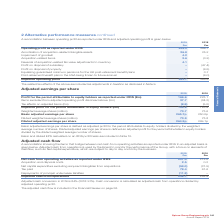According to Spirax Sarco Engineering Plc's financial document, How is basic adjusted earnings per share defined as? adjusted profit for the period attributable to equity holders divided by the weighted average number of shares. The document states: "Basic adjusted earnings per share is defined as adjusted profit for the period attributable to equity holders divided by the weighted average number o..." Also, How is diluted adjusted earnings per share defined as? adjusted profit for the period attributable to equity holders divided by the diluted weighted average number of shares. The document states: "Diluted adjusted earnings per share is defined as adjusted profit for the period attributable to equity holders divided by the diluted weighted averag..." Also, What is the Tax effects on adjusted items for 2018 and 2019 respectively? The document shows two values: (5.0) and (8.5) (in millions). From the document: ".7 (34.2) Tax effects on adjusted items (£m) (8.5) (5.0) Adjusted profit for the period attributable to equity holders (£m) 195.8 183.9 Weighted avera..." Additionally, In which year was the basic adjusted earnings per share larger? According to the financial document, 2019. The relevant text states: "2019 2018 Profit for the period attributable to equity holders as reported under IFRS (£m) 166.6 223.1 I..." Also, can you calculate: What was the change in the profit for the period attributable to equity holders as reported under IFRS in 2019 from 2018? Based on the calculation: 166.6-223.1, the result is -56.5 (in millions). This is based on the information: "ble to equity holders as reported under IFRS (£m) 166.6 223.1 Items excluded from adjusted operating profit disclosed above (£m) 37.7 (34.2) Tax effects on equity holders as reported under IFRS (£m) 1..." The key data points involved are: 166.6, 223.1. Also, can you calculate: What was the percentage change in the profit for the period attributable to equity holders as reported under IFRS in 2019 from 2018? To answer this question, I need to perform calculations using the financial data. The calculation is: (166.6-223.1)/223.1, which equals -25.32 (percentage). This is based on the information: "ble to equity holders as reported under IFRS (£m) 166.6 223.1 Items excluded from adjusted operating profit disclosed above (£m) 37.7 (34.2) Tax effects on equity holders as reported under IFRS (£m) 1..." The key data points involved are: 166.6, 223.1. 